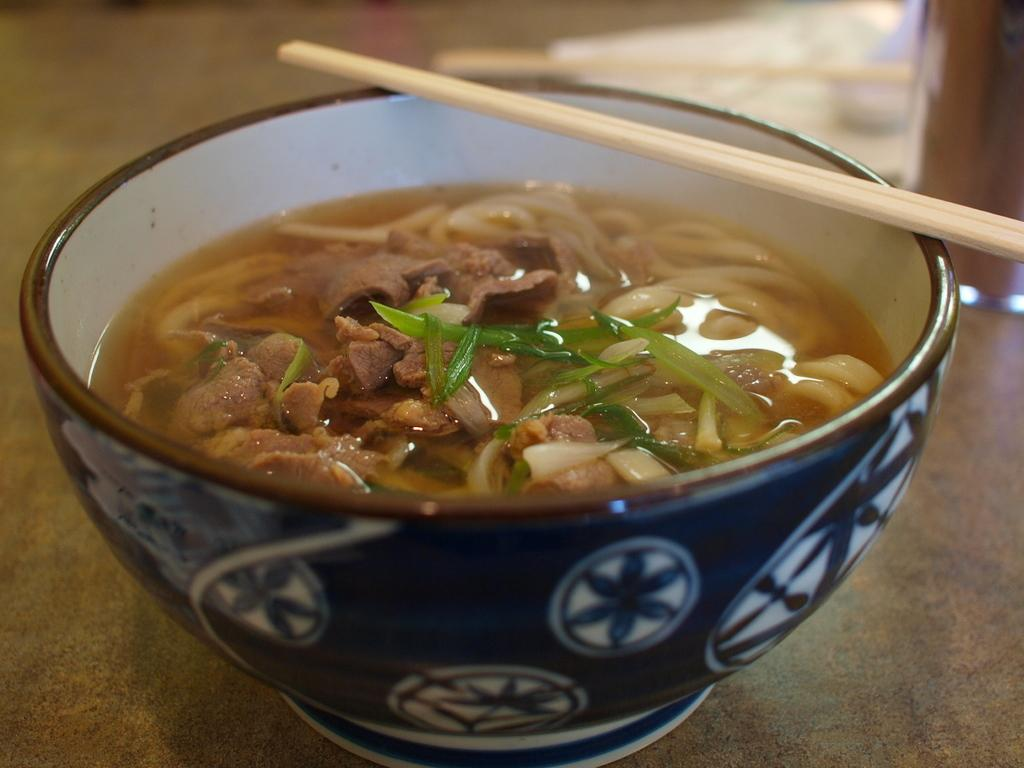What is on the table in the image? There is a bowl on the table in the image. What is inside the bowl? There are pieces of meat, onions, leaves, and water in the bowl. What utensil is placed near the bowl? There are chopsticks on the bowl. What type of holiday is being celebrated in the image? There is no indication of a holiday being celebrated in the image. Can you see any signs of a fight happening in the image? There is no sign of a fight in the image; it features a bowl with various ingredients and chopsticks. 